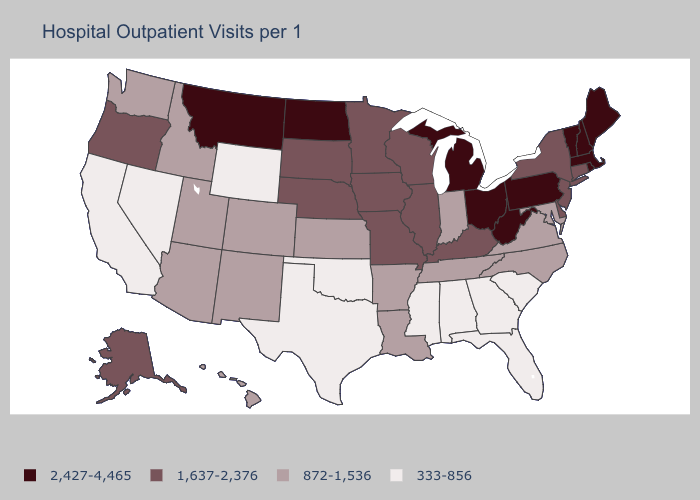Name the states that have a value in the range 2,427-4,465?
Keep it brief. Maine, Massachusetts, Michigan, Montana, New Hampshire, North Dakota, Ohio, Pennsylvania, Rhode Island, Vermont, West Virginia. Which states have the lowest value in the USA?
Write a very short answer. Alabama, California, Florida, Georgia, Mississippi, Nevada, Oklahoma, South Carolina, Texas, Wyoming. What is the highest value in states that border Florida?
Concise answer only. 333-856. What is the value of Iowa?
Keep it brief. 1,637-2,376. Name the states that have a value in the range 872-1,536?
Concise answer only. Arizona, Arkansas, Colorado, Hawaii, Idaho, Indiana, Kansas, Louisiana, Maryland, New Mexico, North Carolina, Tennessee, Utah, Virginia, Washington. Among the states that border Virginia , does Maryland have the highest value?
Write a very short answer. No. What is the highest value in the South ?
Keep it brief. 2,427-4,465. What is the lowest value in states that border Iowa?
Write a very short answer. 1,637-2,376. Does Maine have the same value as Rhode Island?
Keep it brief. Yes. What is the highest value in the USA?
Be succinct. 2,427-4,465. What is the highest value in the MidWest ?
Quick response, please. 2,427-4,465. How many symbols are there in the legend?
Write a very short answer. 4. Among the states that border North Carolina , which have the highest value?
Short answer required. Tennessee, Virginia. Does the map have missing data?
Concise answer only. No. Among the states that border Massachusetts , which have the lowest value?
Be succinct. Connecticut, New York. 